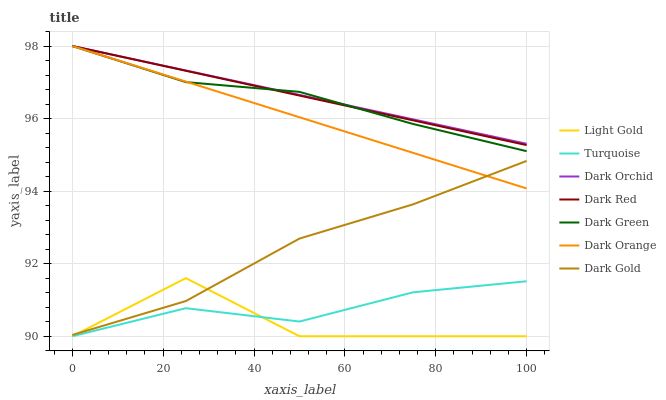Does Light Gold have the minimum area under the curve?
Answer yes or no. Yes. Does Dark Orchid have the maximum area under the curve?
Answer yes or no. Yes. Does Turquoise have the minimum area under the curve?
Answer yes or no. No. Does Turquoise have the maximum area under the curve?
Answer yes or no. No. Is Dark Orange the smoothest?
Answer yes or no. Yes. Is Light Gold the roughest?
Answer yes or no. Yes. Is Turquoise the smoothest?
Answer yes or no. No. Is Turquoise the roughest?
Answer yes or no. No. Does Turquoise have the lowest value?
Answer yes or no. Yes. Does Dark Gold have the lowest value?
Answer yes or no. No. Does Dark Green have the highest value?
Answer yes or no. Yes. Does Dark Gold have the highest value?
Answer yes or no. No. Is Turquoise less than Dark Orchid?
Answer yes or no. Yes. Is Dark Gold greater than Turquoise?
Answer yes or no. Yes. Does Dark Orchid intersect Dark Red?
Answer yes or no. Yes. Is Dark Orchid less than Dark Red?
Answer yes or no. No. Is Dark Orchid greater than Dark Red?
Answer yes or no. No. Does Turquoise intersect Dark Orchid?
Answer yes or no. No. 